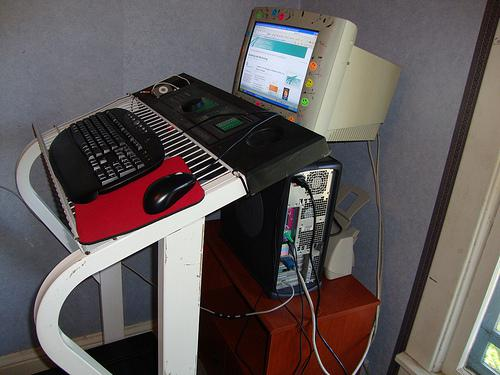Question: what is in the photo?
Choices:
A. A pen.
B. A desk.
C. A computer.
D. Paper.
Answer with the letter. Answer: C Question: what is on top of the computer?
Choices:
A. A shirt.
B. A mouse.
C. A cat.
D. A monitor.
Answer with the letter. Answer: D Question: how many monitors are in the picture?
Choices:
A. Two.
B. Three.
C. Four.
D. One.
Answer with the letter. Answer: D 